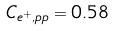Convert formula to latex. <formula><loc_0><loc_0><loc_500><loc_500>C _ { e ^ { + } , p p } = 0 . 5 8</formula> 